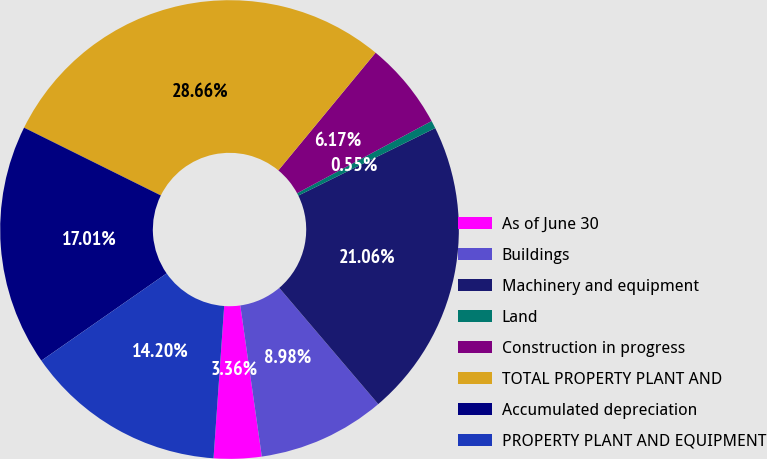<chart> <loc_0><loc_0><loc_500><loc_500><pie_chart><fcel>As of June 30<fcel>Buildings<fcel>Machinery and equipment<fcel>Land<fcel>Construction in progress<fcel>TOTAL PROPERTY PLANT AND<fcel>Accumulated depreciation<fcel>PROPERTY PLANT AND EQUIPMENT<nl><fcel>3.36%<fcel>8.98%<fcel>21.06%<fcel>0.55%<fcel>6.17%<fcel>28.66%<fcel>17.01%<fcel>14.2%<nl></chart> 